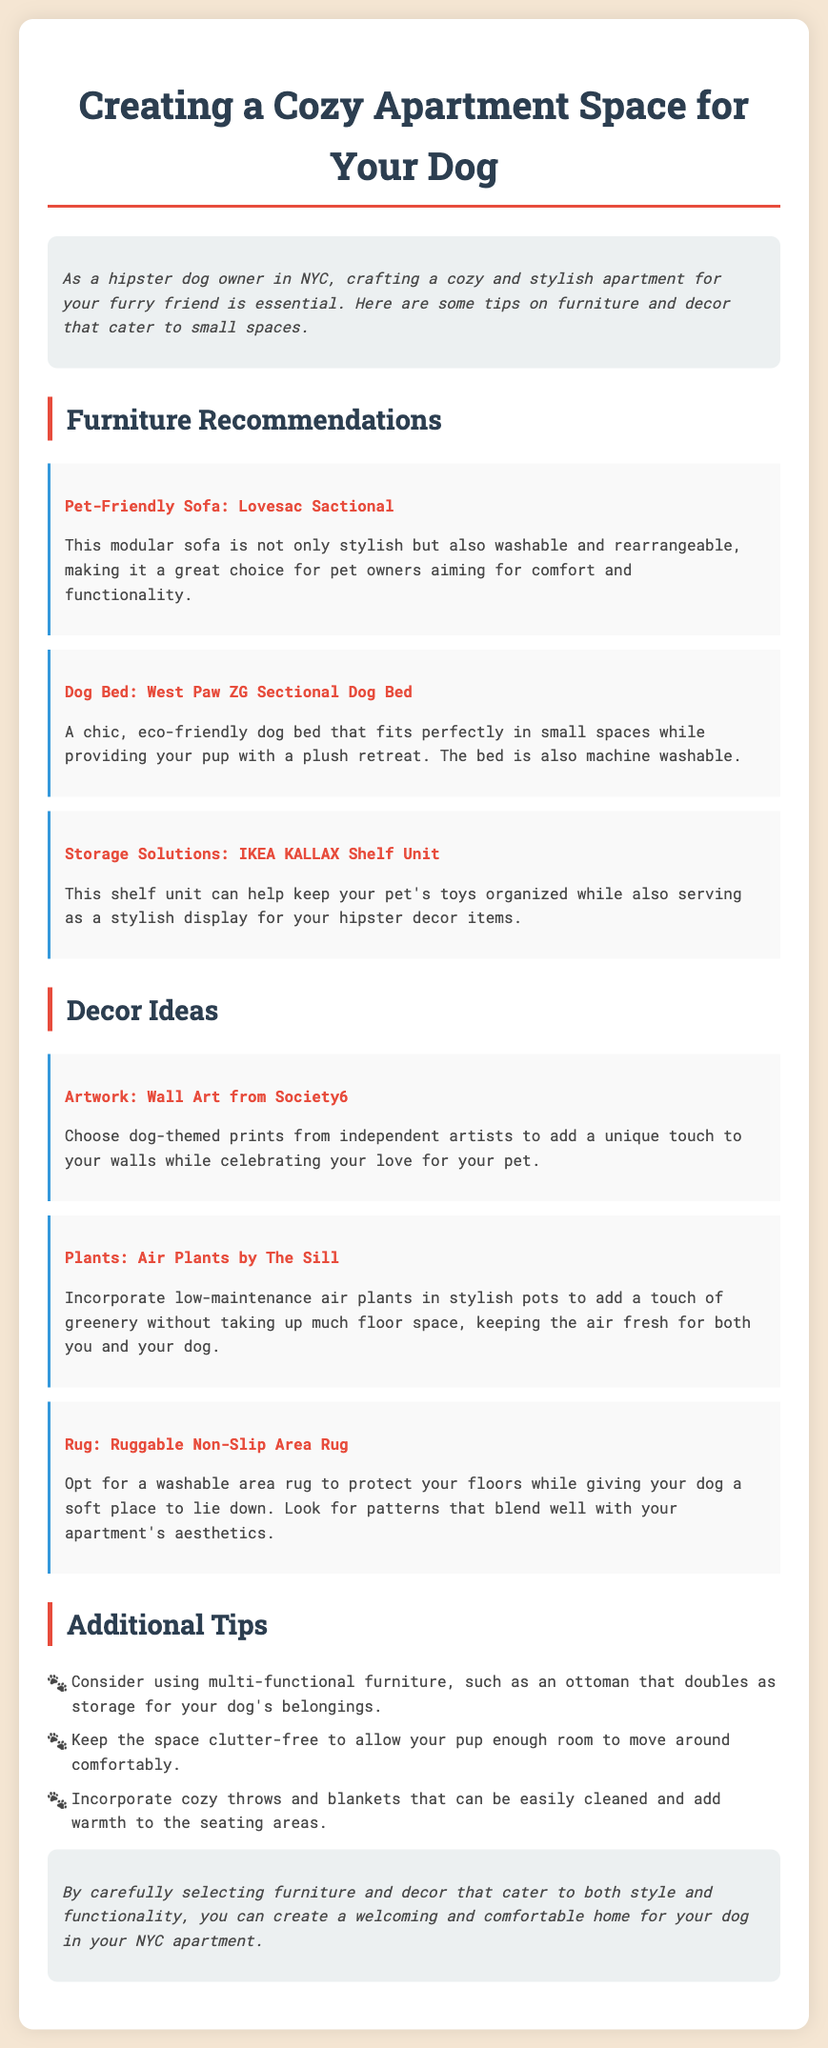What is the title of the memo? The title of the memo is the main heading provided, indicating the content and purpose of the document.
Answer: Creating a Cozy Apartment Space for Your Dog What is a recommended sofa for pet owners? The memo details specific furniture recommendations, including a pet-friendly sofa.
Answer: Lovesac Sactional Which dog bed is mentioned as eco-friendly? The document lists a specific dog bed that is made with eco-friendly materials.
Answer: West Paw ZG Sectional Dog Bed What type of shelf unit is suggested for storage? The memo provides a recommendation for an organizing unit that can accommodate pet toys and decor.
Answer: IKEA KALLAX Shelf Unit Name one decor item that adds greenery. The document includes decor ideas that help bring a natural touch to the apartment while being low maintenance.
Answer: Air Plants by The Sill What is a function of the recommended ottoman? The memo discusses multi-functional furniture options that serve more than one purpose in a small space.
Answer: Storage How can you keep the space clutter-free? The text advises maintaining an open area for dogs to move around, correlating to apartment comfort.
Answer: Clutter-free What benefit does a washable rug provide? The memo explains advantages associated with rugs suitable for pet owners, specifically addressing cleanliness.
Answer: Protects floors What is one of the decor ideas related to art? The document mentions types of wall decorations that suit the theme of dog ownership and small spaces.
Answer: Wall Art from Society6 